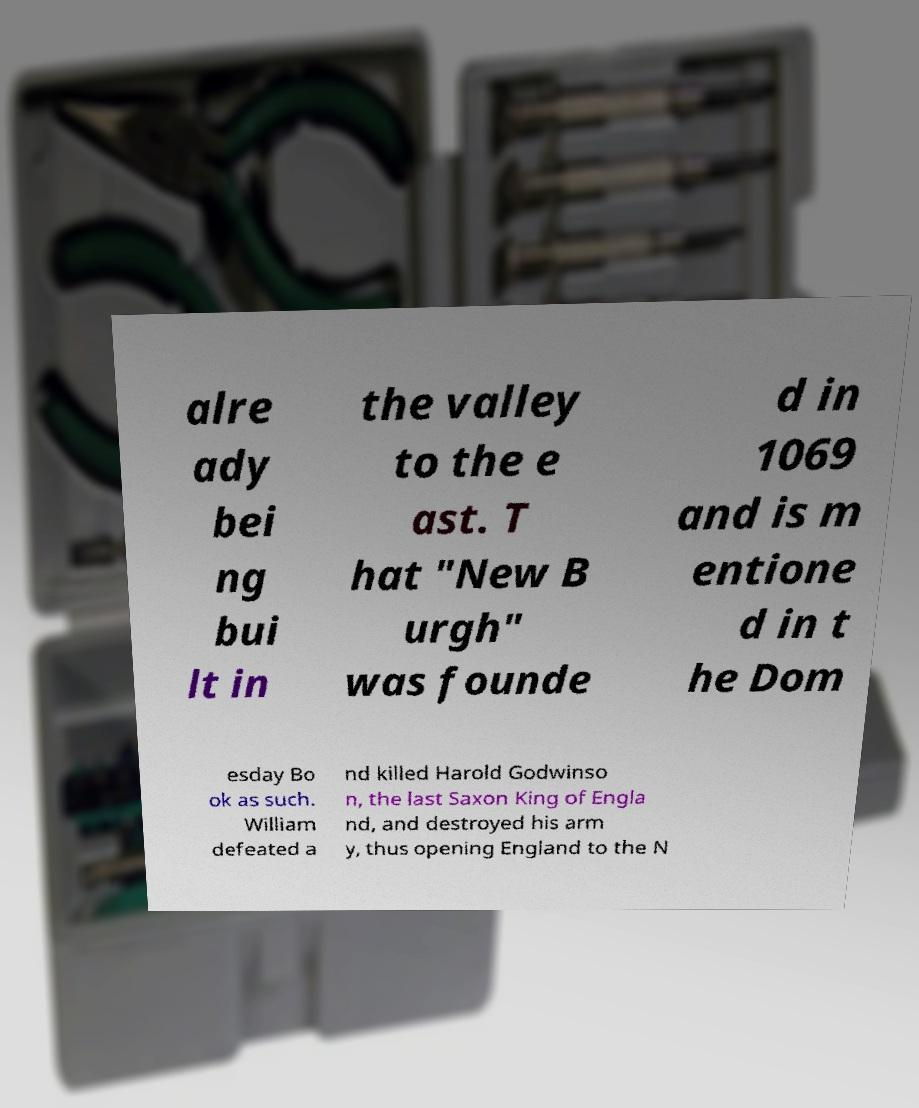For documentation purposes, I need the text within this image transcribed. Could you provide that? alre ady bei ng bui lt in the valley to the e ast. T hat "New B urgh" was founde d in 1069 and is m entione d in t he Dom esday Bo ok as such. William defeated a nd killed Harold Godwinso n, the last Saxon King of Engla nd, and destroyed his arm y, thus opening England to the N 